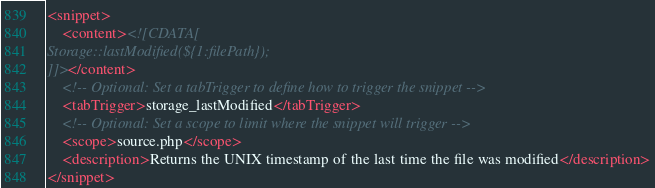<code> <loc_0><loc_0><loc_500><loc_500><_XML_><snippet>
	<content><![CDATA[
Storage::lastModified(${1:filePath});
]]></content>
    <!-- Optional: Set a tabTrigger to define how to trigger the snippet -->
	<tabTrigger>storage_lastModified</tabTrigger>
    <!-- Optional: Set a scope to limit where the snippet will trigger -->
	<scope>source.php</scope>
	<description>Returns the UNIX timestamp of the last time the file was modified</description>
</snippet></code> 